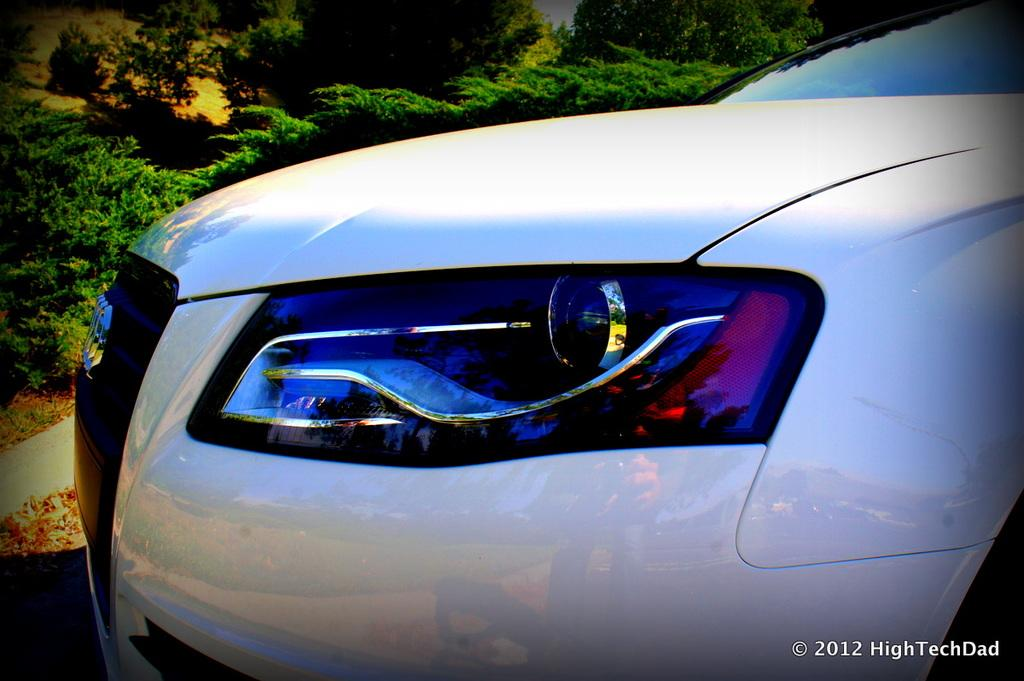What color is the car in the image? The car in the image is white. How is the car positioned in the image? The car is shown from a side view. What part of the car can be seen in the image? The headlights of the car are visible. Is there any additional information or marking on the image? Yes, there is a watermark at the bottom right of the image. How many toes can be seen on the car in the image? There are no toes visible in the image, as it features a car and not a person or animal. 